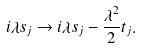<formula> <loc_0><loc_0><loc_500><loc_500>i \lambda s _ { j } \to i \lambda s _ { j } - \frac { \lambda ^ { 2 } } { 2 } t _ { j } .</formula> 